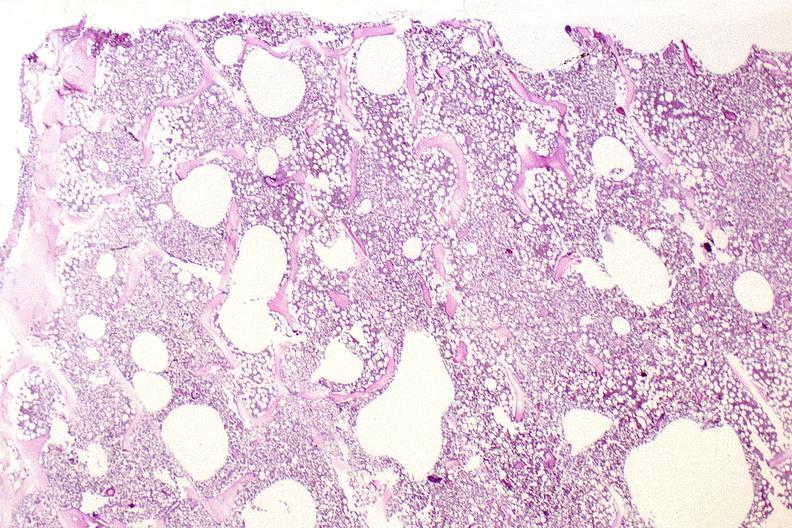s infarction secondary to shock present?
Answer the question using a single word or phrase. No 